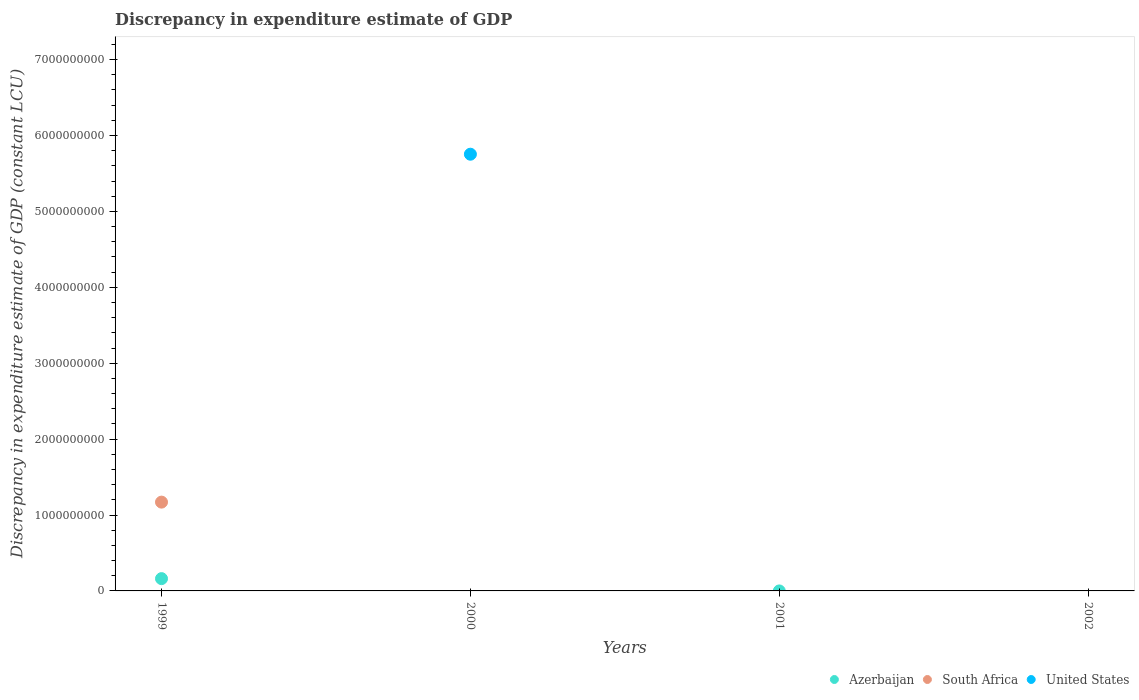How many different coloured dotlines are there?
Provide a succinct answer. 3. What is the discrepancy in expenditure estimate of GDP in South Africa in 1999?
Provide a short and direct response. 1.17e+09. Across all years, what is the maximum discrepancy in expenditure estimate of GDP in South Africa?
Ensure brevity in your answer.  1.17e+09. What is the total discrepancy in expenditure estimate of GDP in South Africa in the graph?
Give a very brief answer. 1.17e+09. What is the difference between the discrepancy in expenditure estimate of GDP in Azerbaijan in 2000 and the discrepancy in expenditure estimate of GDP in South Africa in 2001?
Give a very brief answer. 0. What is the average discrepancy in expenditure estimate of GDP in United States per year?
Ensure brevity in your answer.  1.44e+09. What is the difference between the highest and the lowest discrepancy in expenditure estimate of GDP in Azerbaijan?
Your answer should be very brief. 1.62e+08. Does the discrepancy in expenditure estimate of GDP in United States monotonically increase over the years?
Your response must be concise. No. Is the discrepancy in expenditure estimate of GDP in United States strictly less than the discrepancy in expenditure estimate of GDP in South Africa over the years?
Offer a very short reply. No. How many dotlines are there?
Keep it short and to the point. 3. What is the difference between two consecutive major ticks on the Y-axis?
Your response must be concise. 1.00e+09. Where does the legend appear in the graph?
Your answer should be compact. Bottom right. What is the title of the graph?
Your response must be concise. Discrepancy in expenditure estimate of GDP. Does "Comoros" appear as one of the legend labels in the graph?
Make the answer very short. No. What is the label or title of the X-axis?
Your response must be concise. Years. What is the label or title of the Y-axis?
Provide a short and direct response. Discrepancy in expenditure estimate of GDP (constant LCU). What is the Discrepancy in expenditure estimate of GDP (constant LCU) of Azerbaijan in 1999?
Offer a terse response. 1.62e+08. What is the Discrepancy in expenditure estimate of GDP (constant LCU) in South Africa in 1999?
Provide a succinct answer. 1.17e+09. What is the Discrepancy in expenditure estimate of GDP (constant LCU) of Azerbaijan in 2000?
Your answer should be compact. 0. What is the Discrepancy in expenditure estimate of GDP (constant LCU) of South Africa in 2000?
Make the answer very short. 0. What is the Discrepancy in expenditure estimate of GDP (constant LCU) in United States in 2000?
Your response must be concise. 5.75e+09. What is the Discrepancy in expenditure estimate of GDP (constant LCU) in United States in 2002?
Offer a very short reply. 0. Across all years, what is the maximum Discrepancy in expenditure estimate of GDP (constant LCU) in Azerbaijan?
Your response must be concise. 1.62e+08. Across all years, what is the maximum Discrepancy in expenditure estimate of GDP (constant LCU) in South Africa?
Offer a very short reply. 1.17e+09. Across all years, what is the maximum Discrepancy in expenditure estimate of GDP (constant LCU) of United States?
Ensure brevity in your answer.  5.75e+09. Across all years, what is the minimum Discrepancy in expenditure estimate of GDP (constant LCU) in Azerbaijan?
Your response must be concise. 0. Across all years, what is the minimum Discrepancy in expenditure estimate of GDP (constant LCU) of United States?
Offer a very short reply. 0. What is the total Discrepancy in expenditure estimate of GDP (constant LCU) of Azerbaijan in the graph?
Provide a succinct answer. 1.62e+08. What is the total Discrepancy in expenditure estimate of GDP (constant LCU) in South Africa in the graph?
Your answer should be compact. 1.17e+09. What is the total Discrepancy in expenditure estimate of GDP (constant LCU) in United States in the graph?
Provide a short and direct response. 5.75e+09. What is the difference between the Discrepancy in expenditure estimate of GDP (constant LCU) of Azerbaijan in 1999 and the Discrepancy in expenditure estimate of GDP (constant LCU) of United States in 2000?
Offer a very short reply. -5.59e+09. What is the difference between the Discrepancy in expenditure estimate of GDP (constant LCU) of South Africa in 1999 and the Discrepancy in expenditure estimate of GDP (constant LCU) of United States in 2000?
Your answer should be compact. -4.58e+09. What is the average Discrepancy in expenditure estimate of GDP (constant LCU) in Azerbaijan per year?
Offer a very short reply. 4.05e+07. What is the average Discrepancy in expenditure estimate of GDP (constant LCU) of South Africa per year?
Provide a short and direct response. 2.92e+08. What is the average Discrepancy in expenditure estimate of GDP (constant LCU) in United States per year?
Make the answer very short. 1.44e+09. In the year 1999, what is the difference between the Discrepancy in expenditure estimate of GDP (constant LCU) in Azerbaijan and Discrepancy in expenditure estimate of GDP (constant LCU) in South Africa?
Offer a terse response. -1.01e+09. What is the difference between the highest and the lowest Discrepancy in expenditure estimate of GDP (constant LCU) of Azerbaijan?
Give a very brief answer. 1.62e+08. What is the difference between the highest and the lowest Discrepancy in expenditure estimate of GDP (constant LCU) in South Africa?
Provide a short and direct response. 1.17e+09. What is the difference between the highest and the lowest Discrepancy in expenditure estimate of GDP (constant LCU) of United States?
Offer a terse response. 5.75e+09. 